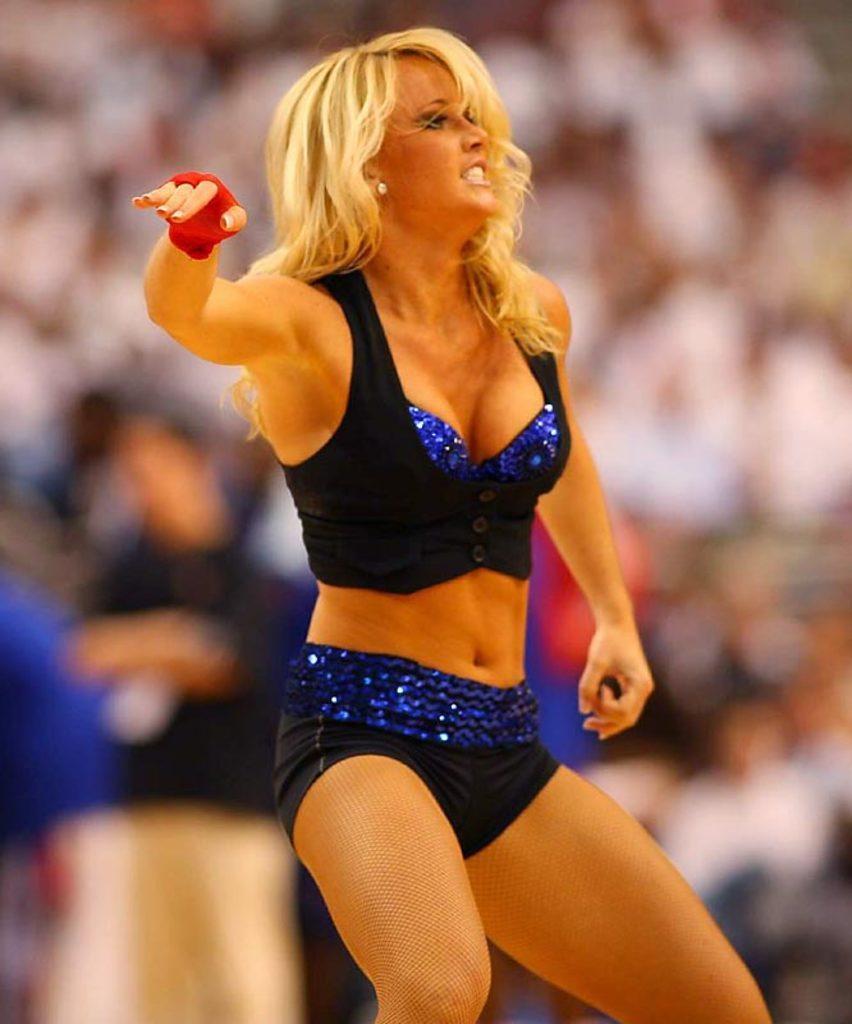Please provide a concise description of this image. In the center of the image we can see women. In the background there is crowd. 